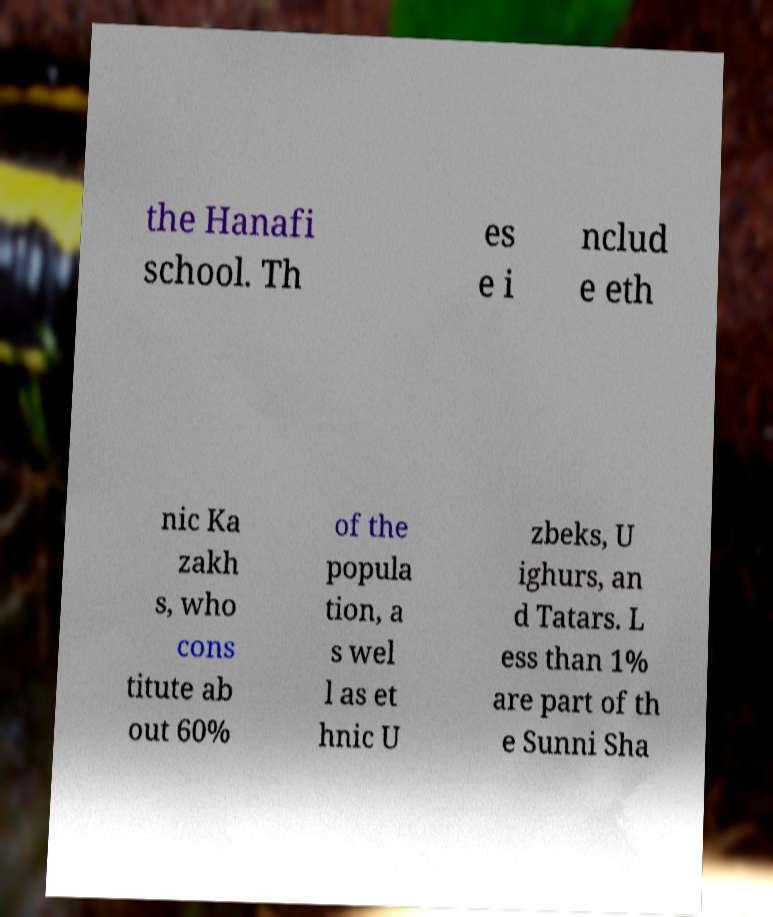Can you read and provide the text displayed in the image?This photo seems to have some interesting text. Can you extract and type it out for me? the Hanafi school. Th es e i nclud e eth nic Ka zakh s, who cons titute ab out 60% of the popula tion, a s wel l as et hnic U zbeks, U ighurs, an d Tatars. L ess than 1% are part of th e Sunni Sha 